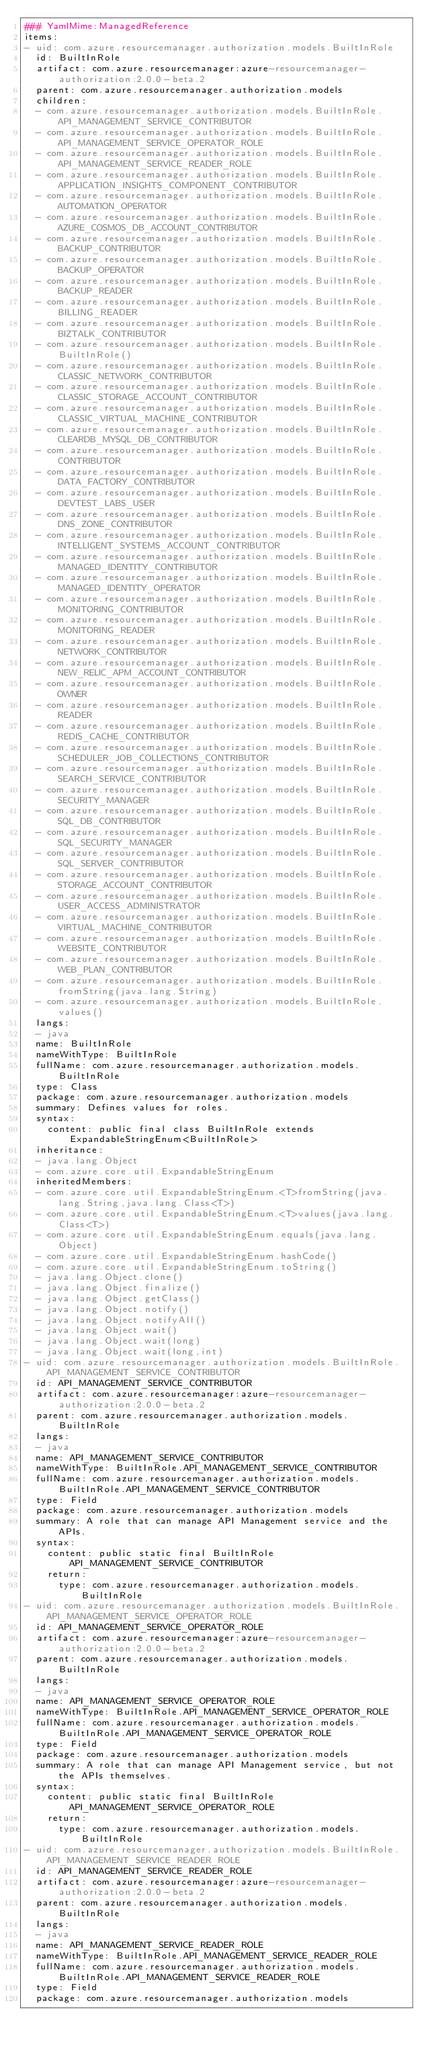<code> <loc_0><loc_0><loc_500><loc_500><_YAML_>### YamlMime:ManagedReference
items:
- uid: com.azure.resourcemanager.authorization.models.BuiltInRole
  id: BuiltInRole
  artifact: com.azure.resourcemanager:azure-resourcemanager-authorization:2.0.0-beta.2
  parent: com.azure.resourcemanager.authorization.models
  children:
  - com.azure.resourcemanager.authorization.models.BuiltInRole.API_MANAGEMENT_SERVICE_CONTRIBUTOR
  - com.azure.resourcemanager.authorization.models.BuiltInRole.API_MANAGEMENT_SERVICE_OPERATOR_ROLE
  - com.azure.resourcemanager.authorization.models.BuiltInRole.API_MANAGEMENT_SERVICE_READER_ROLE
  - com.azure.resourcemanager.authorization.models.BuiltInRole.APPLICATION_INSIGHTS_COMPONENT_CONTRIBUTOR
  - com.azure.resourcemanager.authorization.models.BuiltInRole.AUTOMATION_OPERATOR
  - com.azure.resourcemanager.authorization.models.BuiltInRole.AZURE_COSMOS_DB_ACCOUNT_CONTRIBUTOR
  - com.azure.resourcemanager.authorization.models.BuiltInRole.BACKUP_CONTRIBUTOR
  - com.azure.resourcemanager.authorization.models.BuiltInRole.BACKUP_OPERATOR
  - com.azure.resourcemanager.authorization.models.BuiltInRole.BACKUP_READER
  - com.azure.resourcemanager.authorization.models.BuiltInRole.BILLING_READER
  - com.azure.resourcemanager.authorization.models.BuiltInRole.BIZTALK_CONTRIBUTOR
  - com.azure.resourcemanager.authorization.models.BuiltInRole.BuiltInRole()
  - com.azure.resourcemanager.authorization.models.BuiltInRole.CLASSIC_NETWORK_CONTRIBUTOR
  - com.azure.resourcemanager.authorization.models.BuiltInRole.CLASSIC_STORAGE_ACCOUNT_CONTRIBUTOR
  - com.azure.resourcemanager.authorization.models.BuiltInRole.CLASSIC_VIRTUAL_MACHINE_CONTRIBUTOR
  - com.azure.resourcemanager.authorization.models.BuiltInRole.CLEARDB_MYSQL_DB_CONTRIBUTOR
  - com.azure.resourcemanager.authorization.models.BuiltInRole.CONTRIBUTOR
  - com.azure.resourcemanager.authorization.models.BuiltInRole.DATA_FACTORY_CONTRIBUTOR
  - com.azure.resourcemanager.authorization.models.BuiltInRole.DEVTEST_LABS_USER
  - com.azure.resourcemanager.authorization.models.BuiltInRole.DNS_ZONE_CONTRIBUTOR
  - com.azure.resourcemanager.authorization.models.BuiltInRole.INTELLIGENT_SYSTEMS_ACCOUNT_CONTRIBUTOR
  - com.azure.resourcemanager.authorization.models.BuiltInRole.MANAGED_IDENTITY_CONTRIBUTOR
  - com.azure.resourcemanager.authorization.models.BuiltInRole.MANAGED_IDENTITY_OPERATOR
  - com.azure.resourcemanager.authorization.models.BuiltInRole.MONITORING_CONTRIBUTOR
  - com.azure.resourcemanager.authorization.models.BuiltInRole.MONITORING_READER
  - com.azure.resourcemanager.authorization.models.BuiltInRole.NETWORK_CONTRIBUTOR
  - com.azure.resourcemanager.authorization.models.BuiltInRole.NEW_RELIC_APM_ACCOUNT_CONTRIBUTOR
  - com.azure.resourcemanager.authorization.models.BuiltInRole.OWNER
  - com.azure.resourcemanager.authorization.models.BuiltInRole.READER
  - com.azure.resourcemanager.authorization.models.BuiltInRole.REDIS_CACHE_CONTRIBUTOR
  - com.azure.resourcemanager.authorization.models.BuiltInRole.SCHEDULER_JOB_COLLECTIONS_CONTRIBUTOR
  - com.azure.resourcemanager.authorization.models.BuiltInRole.SEARCH_SERVICE_CONTRIBUTOR
  - com.azure.resourcemanager.authorization.models.BuiltInRole.SECURITY_MANAGER
  - com.azure.resourcemanager.authorization.models.BuiltInRole.SQL_DB_CONTRIBUTOR
  - com.azure.resourcemanager.authorization.models.BuiltInRole.SQL_SECURITY_MANAGER
  - com.azure.resourcemanager.authorization.models.BuiltInRole.SQL_SERVER_CONTRIBUTOR
  - com.azure.resourcemanager.authorization.models.BuiltInRole.STORAGE_ACCOUNT_CONTRIBUTOR
  - com.azure.resourcemanager.authorization.models.BuiltInRole.USER_ACCESS_ADMINISTRATOR
  - com.azure.resourcemanager.authorization.models.BuiltInRole.VIRTUAL_MACHINE_CONTRIBUTOR
  - com.azure.resourcemanager.authorization.models.BuiltInRole.WEBSITE_CONTRIBUTOR
  - com.azure.resourcemanager.authorization.models.BuiltInRole.WEB_PLAN_CONTRIBUTOR
  - com.azure.resourcemanager.authorization.models.BuiltInRole.fromString(java.lang.String)
  - com.azure.resourcemanager.authorization.models.BuiltInRole.values()
  langs:
  - java
  name: BuiltInRole
  nameWithType: BuiltInRole
  fullName: com.azure.resourcemanager.authorization.models.BuiltInRole
  type: Class
  package: com.azure.resourcemanager.authorization.models
  summary: Defines values for roles.
  syntax:
    content: public final class BuiltInRole extends ExpandableStringEnum<BuiltInRole>
  inheritance:
  - java.lang.Object
  - com.azure.core.util.ExpandableStringEnum
  inheritedMembers:
  - com.azure.core.util.ExpandableStringEnum.<T>fromString(java.lang.String,java.lang.Class<T>)
  - com.azure.core.util.ExpandableStringEnum.<T>values(java.lang.Class<T>)
  - com.azure.core.util.ExpandableStringEnum.equals(java.lang.Object)
  - com.azure.core.util.ExpandableStringEnum.hashCode()
  - com.azure.core.util.ExpandableStringEnum.toString()
  - java.lang.Object.clone()
  - java.lang.Object.finalize()
  - java.lang.Object.getClass()
  - java.lang.Object.notify()
  - java.lang.Object.notifyAll()
  - java.lang.Object.wait()
  - java.lang.Object.wait(long)
  - java.lang.Object.wait(long,int)
- uid: com.azure.resourcemanager.authorization.models.BuiltInRole.API_MANAGEMENT_SERVICE_CONTRIBUTOR
  id: API_MANAGEMENT_SERVICE_CONTRIBUTOR
  artifact: com.azure.resourcemanager:azure-resourcemanager-authorization:2.0.0-beta.2
  parent: com.azure.resourcemanager.authorization.models.BuiltInRole
  langs:
  - java
  name: API_MANAGEMENT_SERVICE_CONTRIBUTOR
  nameWithType: BuiltInRole.API_MANAGEMENT_SERVICE_CONTRIBUTOR
  fullName: com.azure.resourcemanager.authorization.models.BuiltInRole.API_MANAGEMENT_SERVICE_CONTRIBUTOR
  type: Field
  package: com.azure.resourcemanager.authorization.models
  summary: A role that can manage API Management service and the APIs.
  syntax:
    content: public static final BuiltInRole API_MANAGEMENT_SERVICE_CONTRIBUTOR
    return:
      type: com.azure.resourcemanager.authorization.models.BuiltInRole
- uid: com.azure.resourcemanager.authorization.models.BuiltInRole.API_MANAGEMENT_SERVICE_OPERATOR_ROLE
  id: API_MANAGEMENT_SERVICE_OPERATOR_ROLE
  artifact: com.azure.resourcemanager:azure-resourcemanager-authorization:2.0.0-beta.2
  parent: com.azure.resourcemanager.authorization.models.BuiltInRole
  langs:
  - java
  name: API_MANAGEMENT_SERVICE_OPERATOR_ROLE
  nameWithType: BuiltInRole.API_MANAGEMENT_SERVICE_OPERATOR_ROLE
  fullName: com.azure.resourcemanager.authorization.models.BuiltInRole.API_MANAGEMENT_SERVICE_OPERATOR_ROLE
  type: Field
  package: com.azure.resourcemanager.authorization.models
  summary: A role that can manage API Management service, but not the APIs themselves.
  syntax:
    content: public static final BuiltInRole API_MANAGEMENT_SERVICE_OPERATOR_ROLE
    return:
      type: com.azure.resourcemanager.authorization.models.BuiltInRole
- uid: com.azure.resourcemanager.authorization.models.BuiltInRole.API_MANAGEMENT_SERVICE_READER_ROLE
  id: API_MANAGEMENT_SERVICE_READER_ROLE
  artifact: com.azure.resourcemanager:azure-resourcemanager-authorization:2.0.0-beta.2
  parent: com.azure.resourcemanager.authorization.models.BuiltInRole
  langs:
  - java
  name: API_MANAGEMENT_SERVICE_READER_ROLE
  nameWithType: BuiltInRole.API_MANAGEMENT_SERVICE_READER_ROLE
  fullName: com.azure.resourcemanager.authorization.models.BuiltInRole.API_MANAGEMENT_SERVICE_READER_ROLE
  type: Field
  package: com.azure.resourcemanager.authorization.models</code> 